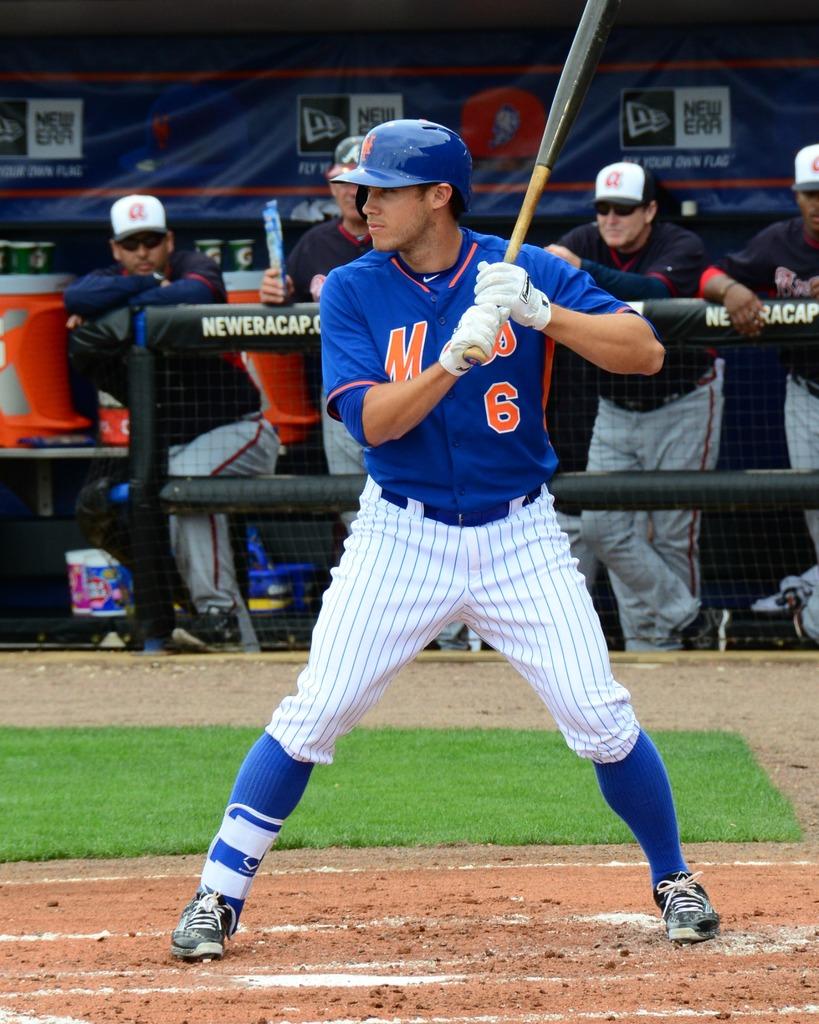What company makes the caps that the players in the dugout are wearing?
Provide a succinct answer. New era. What number is on the jersey?
Offer a very short reply. 6. 